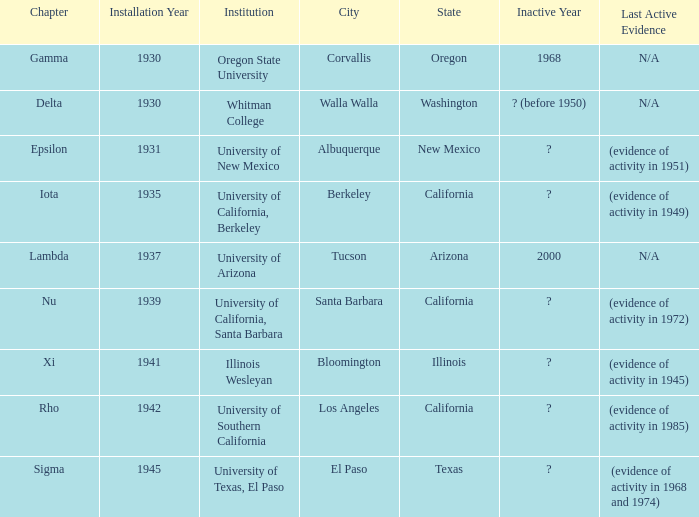What is the installation date for the Delta Chapter? Cannot handle non-empty timestamp argument! 1930. 